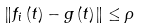Convert formula to latex. <formula><loc_0><loc_0><loc_500><loc_500>\left \| f _ { i } \left ( t \right ) - g \left ( t \right ) \right \| \leq \rho</formula> 